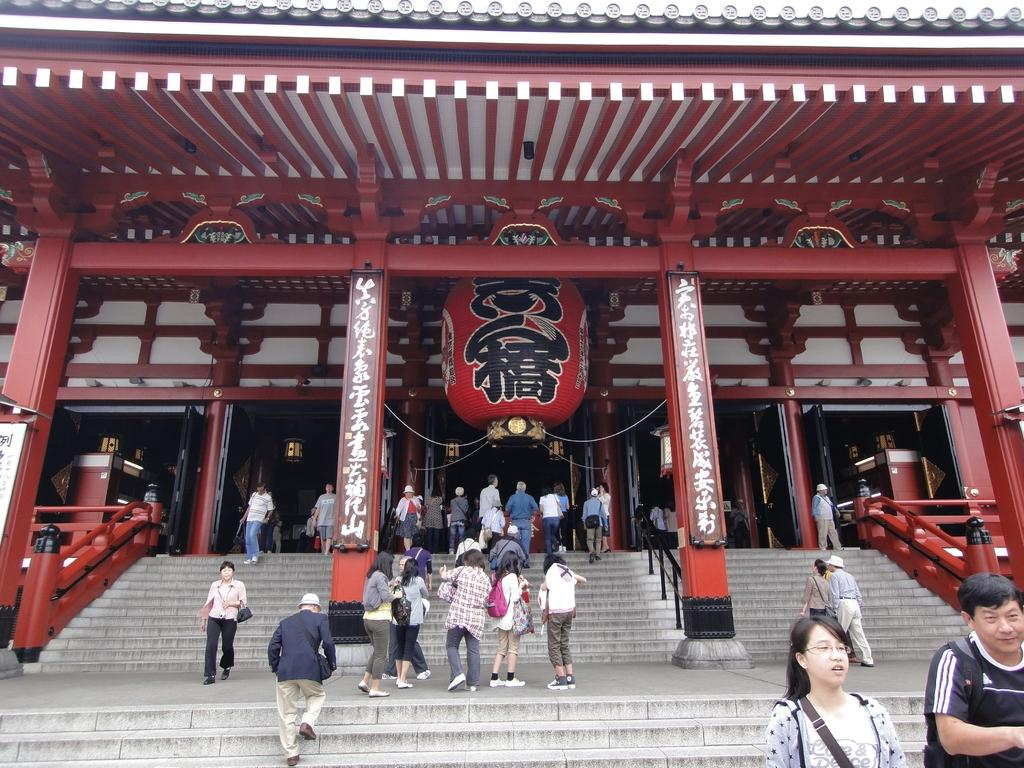How many people are in the image? There is a group of people in the image. What architectural features can be seen in the image? There are pillars in the image. What objects are present in the image? There are boards in the image. What type of structure is visible in the image? There is a building in the image. Are there any slaves visible in the image? There is no indication of any slaves or slavery-related activities in the image. 